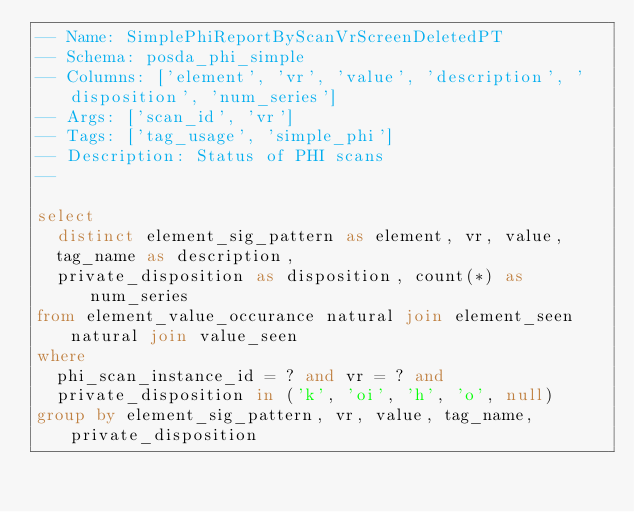Convert code to text. <code><loc_0><loc_0><loc_500><loc_500><_SQL_>-- Name: SimplePhiReportByScanVrScreenDeletedPT
-- Schema: posda_phi_simple
-- Columns: ['element', 'vr', 'value', 'description', 'disposition', 'num_series']
-- Args: ['scan_id', 'vr']
-- Tags: ['tag_usage', 'simple_phi']
-- Description: Status of PHI scans
-- 

select 
  distinct element_sig_pattern as element, vr, value, 
  tag_name as description, 
  private_disposition as disposition, count(*) as num_series
from element_value_occurance natural join element_seen natural join value_seen
where 
  phi_scan_instance_id = ? and vr = ? and
  private_disposition in ('k', 'oi', 'h', 'o', null)
group by element_sig_pattern, vr, value, tag_name, private_disposition</code> 